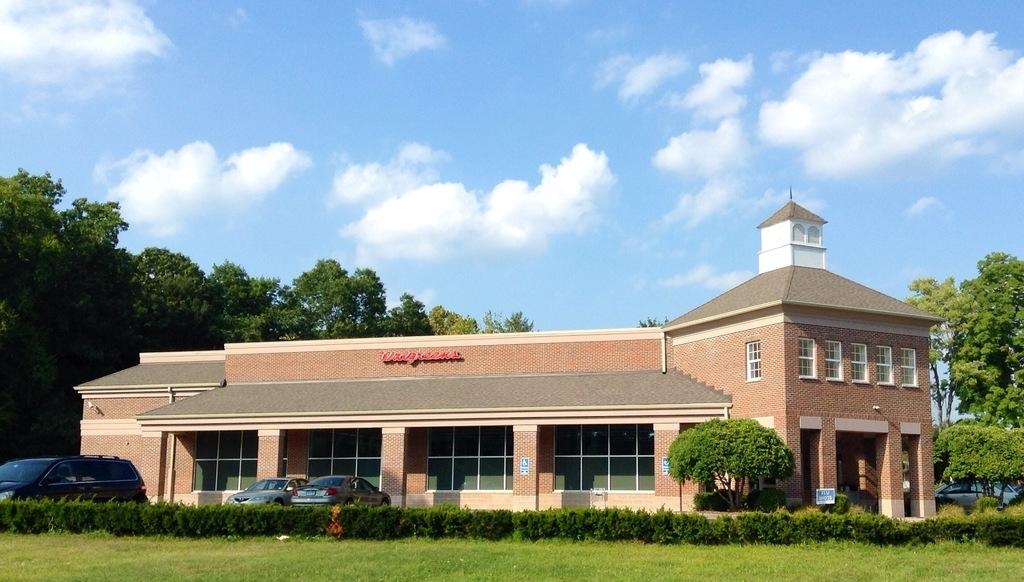What type of vegetation is present in the image? There is grass and plants in the image. What else can be seen in the image besides vegetation? There are vehicles, trees, a building with windows, and the sky visible in the background. Can you describe the building in the image? The building has windows. What is visible in the sky in the image? The sky is visible in the background of the image, and there are clouds present. What type of oven is visible in the image? There is no oven present in the image. Can you describe the fight between the vehicles in the image? There is no fight between vehicles depicted in the image; the vehicles are stationary. 